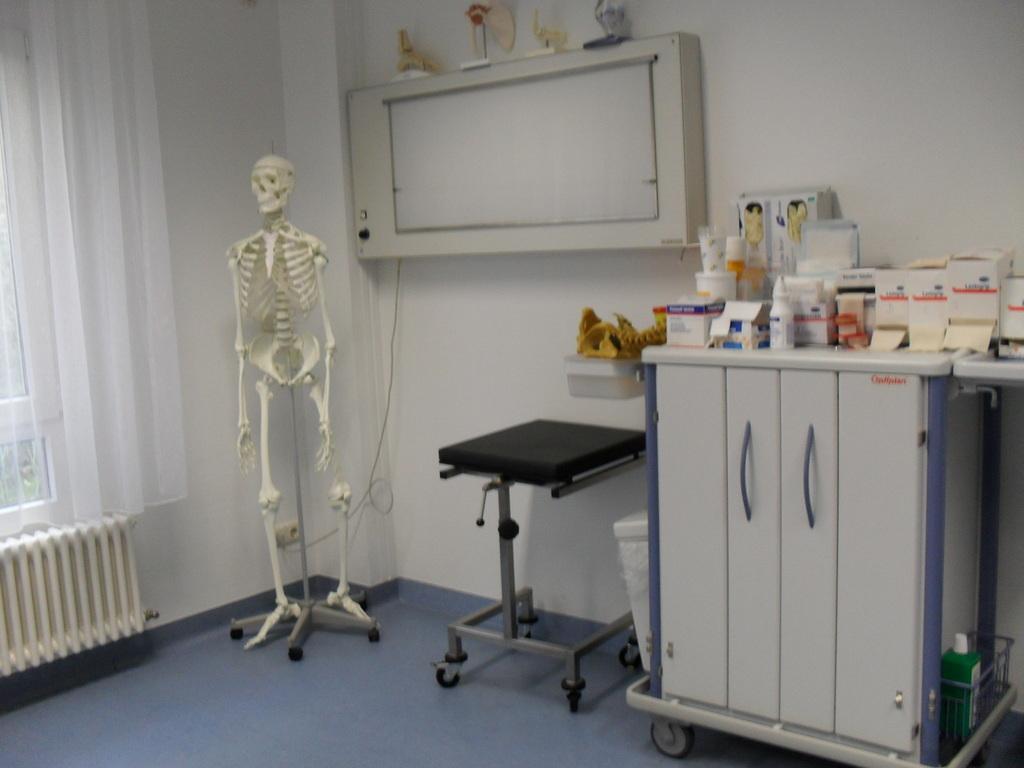Describe this image in one or two sentences. In the image we can see there is a skeleton kept on the stand and there is a curtain on the window. There are medicines kept on the table. 